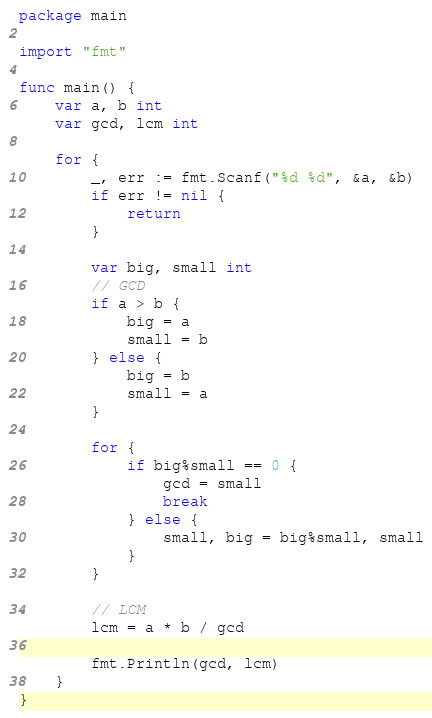<code> <loc_0><loc_0><loc_500><loc_500><_Go_>package main

import "fmt"

func main() {
	var a, b int
	var gcd, lcm int

	for {
		_, err := fmt.Scanf("%d %d", &a, &b)
		if err != nil {
			return
		}

		var big, small int
		// GCD
		if a > b {
			big = a
			small = b
		} else {
			big = b
			small = a
		}

		for {
			if big%small == 0 {
				gcd = small
				break
			} else {
				small, big = big%small, small
			}
		}

		// LCM
		lcm = a * b / gcd

		fmt.Println(gcd, lcm)
	}
}

</code> 